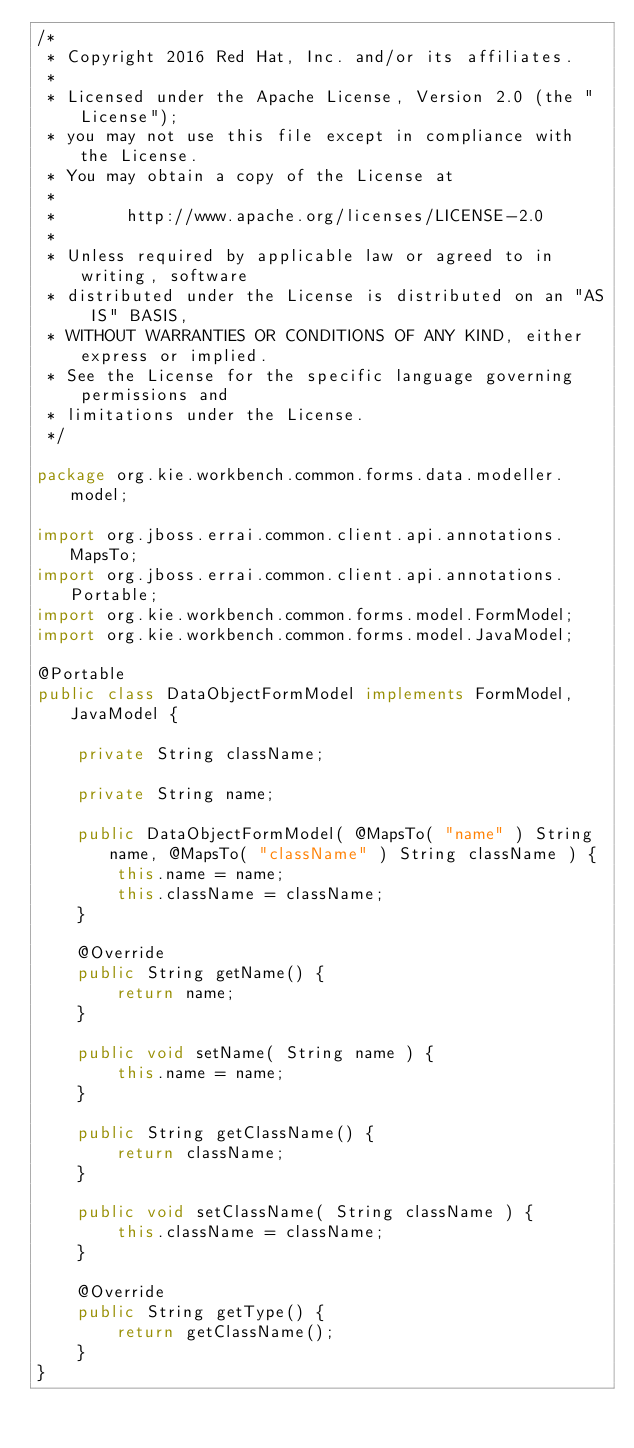<code> <loc_0><loc_0><loc_500><loc_500><_Java_>/*
 * Copyright 2016 Red Hat, Inc. and/or its affiliates.
 *
 * Licensed under the Apache License, Version 2.0 (the "License");
 * you may not use this file except in compliance with the License.
 * You may obtain a copy of the License at
 *
 *       http://www.apache.org/licenses/LICENSE-2.0
 *
 * Unless required by applicable law or agreed to in writing, software
 * distributed under the License is distributed on an "AS IS" BASIS,
 * WITHOUT WARRANTIES OR CONDITIONS OF ANY KIND, either express or implied.
 * See the License for the specific language governing permissions and
 * limitations under the License.
 */

package org.kie.workbench.common.forms.data.modeller.model;

import org.jboss.errai.common.client.api.annotations.MapsTo;
import org.jboss.errai.common.client.api.annotations.Portable;
import org.kie.workbench.common.forms.model.FormModel;
import org.kie.workbench.common.forms.model.JavaModel;

@Portable
public class DataObjectFormModel implements FormModel, JavaModel {

    private String className;

    private String name;

    public DataObjectFormModel( @MapsTo( "name" ) String name, @MapsTo( "className" ) String className ) {
        this.name = name;
        this.className = className;
    }

    @Override
    public String getName() {
        return name;
    }

    public void setName( String name ) {
        this.name = name;
    }

    public String getClassName() {
        return className;
    }

    public void setClassName( String className ) {
        this.className = className;
    }

    @Override
    public String getType() {
        return getClassName();
    }
}
</code> 